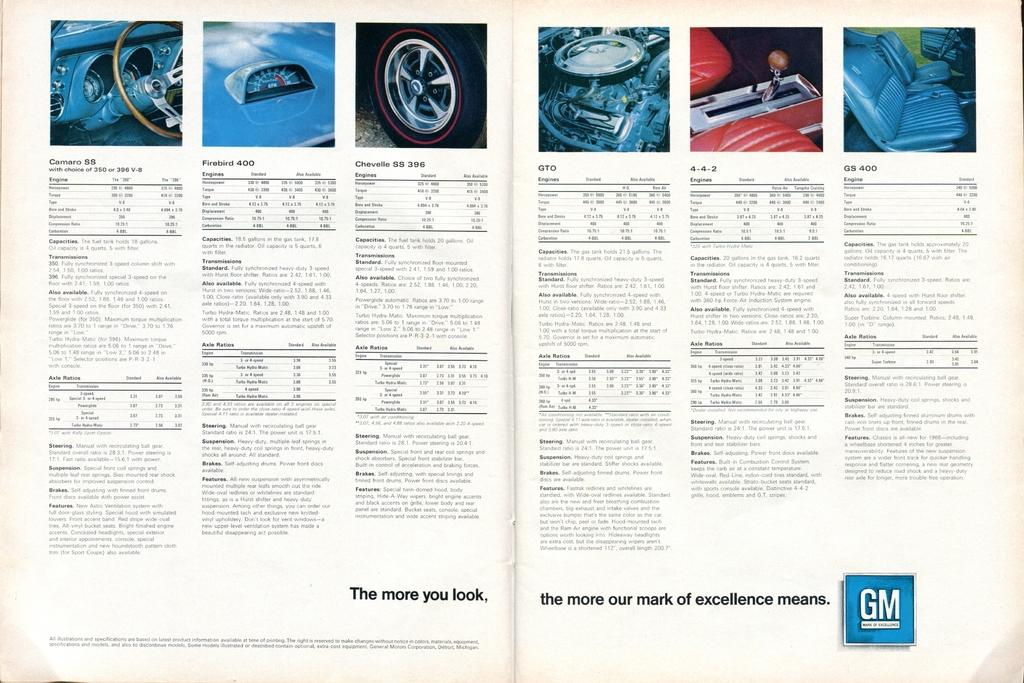What is featured in the image? There is a poster in the image. What can be found on the poster? The poster includes written text and images. What type of insurance is advertised on the poster? There is no mention of insurance on the poster, as it only includes written text and images. 